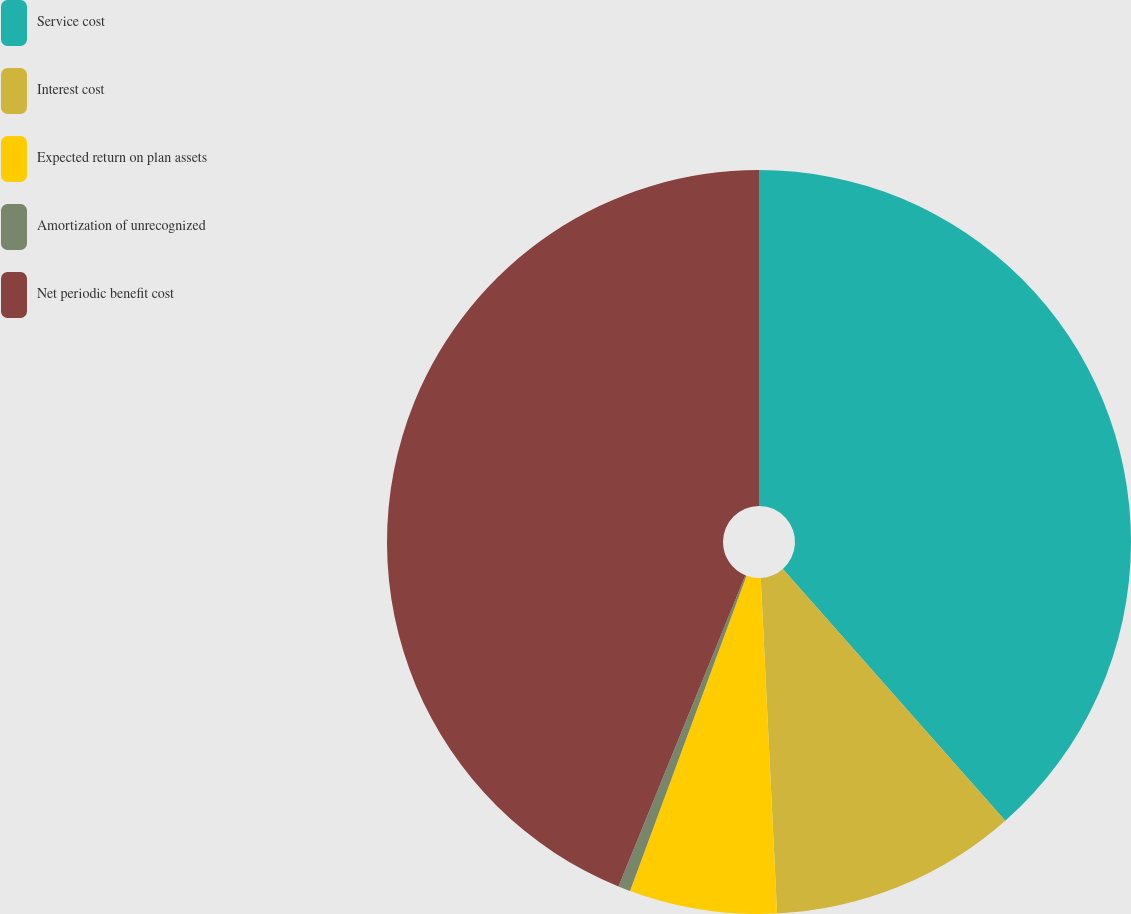Convert chart to OTSL. <chart><loc_0><loc_0><loc_500><loc_500><pie_chart><fcel>Service cost<fcel>Interest cost<fcel>Expected return on plan assets<fcel>Amortization of unrecognized<fcel>Net periodic benefit cost<nl><fcel>38.48%<fcel>10.74%<fcel>6.41%<fcel>0.53%<fcel>43.83%<nl></chart> 